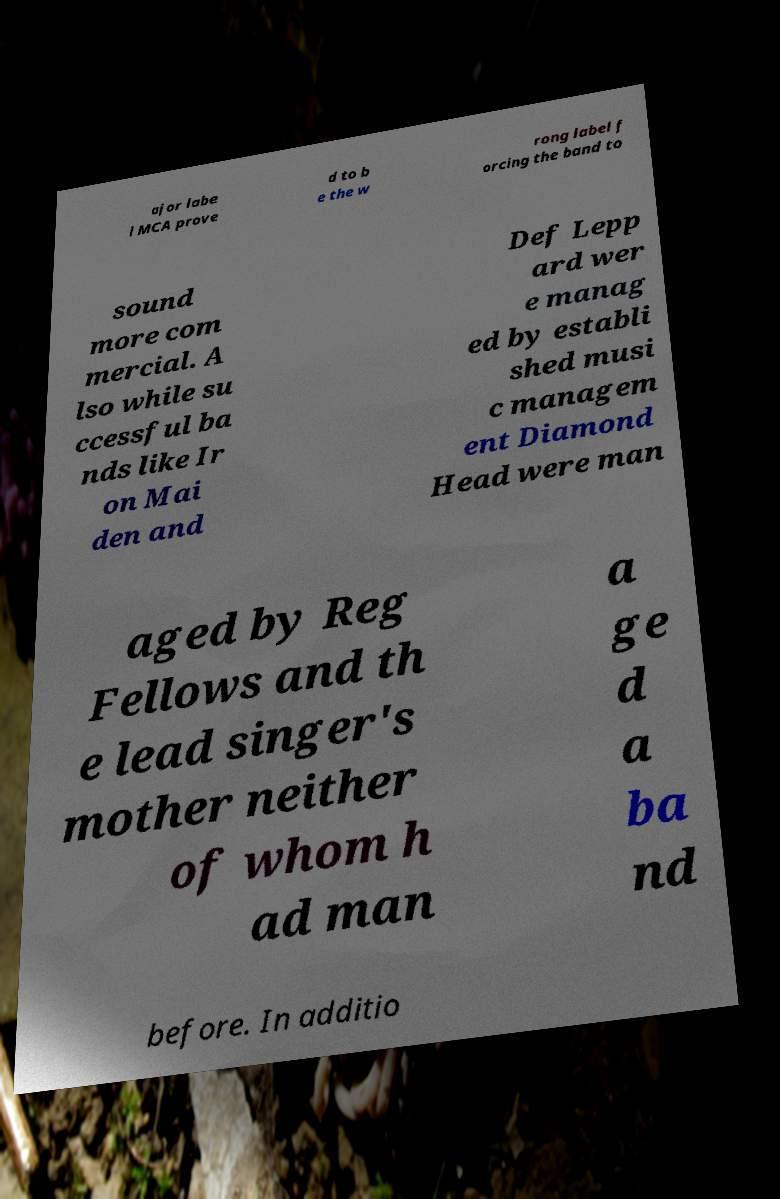For documentation purposes, I need the text within this image transcribed. Could you provide that? ajor labe l MCA prove d to b e the w rong label f orcing the band to sound more com mercial. A lso while su ccessful ba nds like Ir on Mai den and Def Lepp ard wer e manag ed by establi shed musi c managem ent Diamond Head were man aged by Reg Fellows and th e lead singer's mother neither of whom h ad man a ge d a ba nd before. In additio 